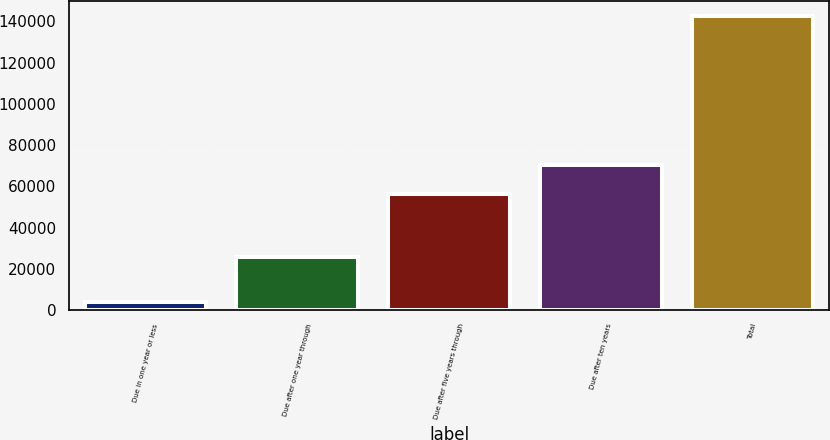<chart> <loc_0><loc_0><loc_500><loc_500><bar_chart><fcel>Due in one year or less<fcel>Due after one year through<fcel>Due after five years through<fcel>Due after ten years<fcel>Total<nl><fcel>3882<fcel>25919<fcel>56204<fcel>70094.9<fcel>142791<nl></chart> 